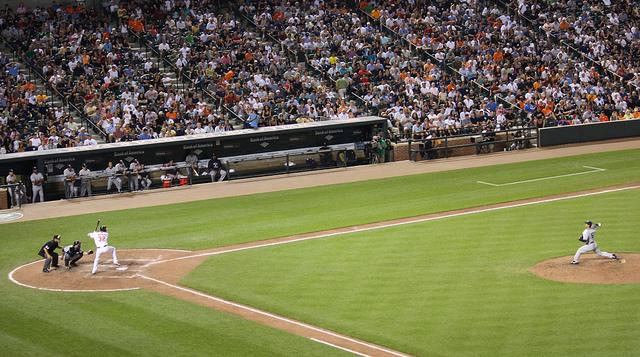The man wearing what color of shirt is responsible for rendering decisions on judgment calls? black 